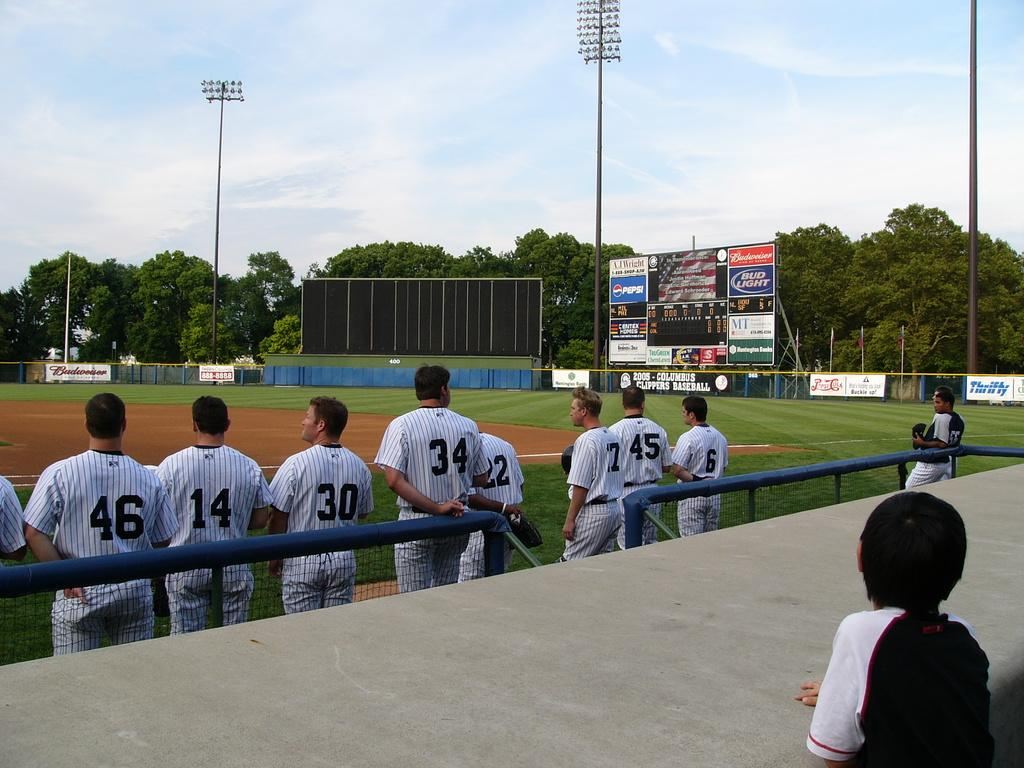What are the people in the image doing? The people in the image are standing in the center. What can be seen in the image besides the people? There is a fence, a boy on the right side, trees, poles, boards, and the sky visible in the background. What type of science experiment is being conducted in the image? There is no science experiment present in the image. What liquid is being poured from the sock in the image? There is no sock or liquid present in the image. 